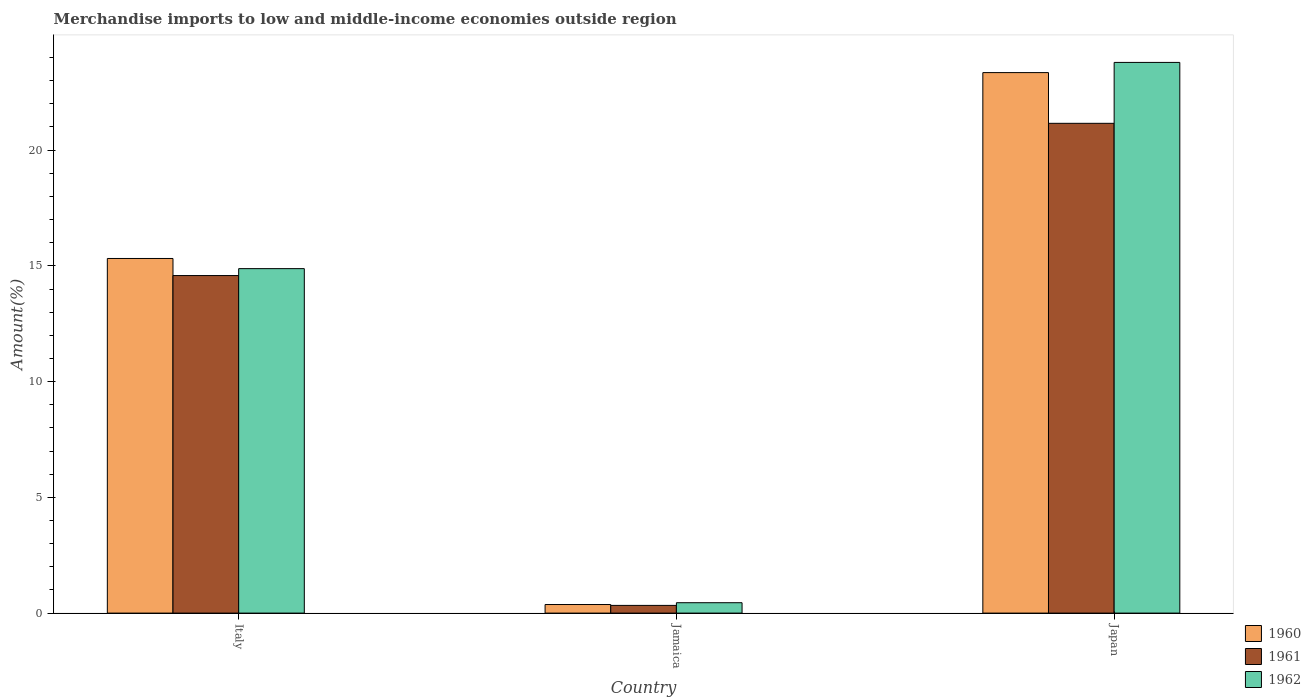How many different coloured bars are there?
Offer a very short reply. 3. How many bars are there on the 1st tick from the left?
Keep it short and to the point. 3. What is the label of the 2nd group of bars from the left?
Your answer should be very brief. Jamaica. What is the percentage of amount earned from merchandise imports in 1960 in Italy?
Your answer should be very brief. 15.32. Across all countries, what is the maximum percentage of amount earned from merchandise imports in 1960?
Offer a very short reply. 23.35. Across all countries, what is the minimum percentage of amount earned from merchandise imports in 1962?
Your answer should be very brief. 0.45. In which country was the percentage of amount earned from merchandise imports in 1962 minimum?
Keep it short and to the point. Jamaica. What is the total percentage of amount earned from merchandise imports in 1961 in the graph?
Your answer should be compact. 36.07. What is the difference between the percentage of amount earned from merchandise imports in 1962 in Jamaica and that in Japan?
Make the answer very short. -23.34. What is the difference between the percentage of amount earned from merchandise imports in 1962 in Jamaica and the percentage of amount earned from merchandise imports in 1961 in Japan?
Your answer should be compact. -20.71. What is the average percentage of amount earned from merchandise imports in 1962 per country?
Your answer should be compact. 13.04. What is the difference between the percentage of amount earned from merchandise imports of/in 1961 and percentage of amount earned from merchandise imports of/in 1962 in Jamaica?
Keep it short and to the point. -0.12. In how many countries, is the percentage of amount earned from merchandise imports in 1960 greater than 19 %?
Your answer should be very brief. 1. What is the ratio of the percentage of amount earned from merchandise imports in 1960 in Italy to that in Jamaica?
Give a very brief answer. 41.38. Is the percentage of amount earned from merchandise imports in 1961 in Italy less than that in Jamaica?
Provide a short and direct response. No. Is the difference between the percentage of amount earned from merchandise imports in 1961 in Jamaica and Japan greater than the difference between the percentage of amount earned from merchandise imports in 1962 in Jamaica and Japan?
Your answer should be very brief. Yes. What is the difference between the highest and the second highest percentage of amount earned from merchandise imports in 1960?
Make the answer very short. -14.95. What is the difference between the highest and the lowest percentage of amount earned from merchandise imports in 1962?
Provide a short and direct response. 23.34. Is the sum of the percentage of amount earned from merchandise imports in 1960 in Jamaica and Japan greater than the maximum percentage of amount earned from merchandise imports in 1961 across all countries?
Ensure brevity in your answer.  Yes. What does the 1st bar from the left in Japan represents?
Make the answer very short. 1960. What does the 1st bar from the right in Japan represents?
Your answer should be compact. 1962. Is it the case that in every country, the sum of the percentage of amount earned from merchandise imports in 1961 and percentage of amount earned from merchandise imports in 1960 is greater than the percentage of amount earned from merchandise imports in 1962?
Keep it short and to the point. Yes. How many bars are there?
Ensure brevity in your answer.  9. Are the values on the major ticks of Y-axis written in scientific E-notation?
Provide a succinct answer. No. Does the graph contain any zero values?
Ensure brevity in your answer.  No. Where does the legend appear in the graph?
Your response must be concise. Bottom right. How many legend labels are there?
Offer a very short reply. 3. How are the legend labels stacked?
Your answer should be very brief. Vertical. What is the title of the graph?
Your response must be concise. Merchandise imports to low and middle-income economies outside region. What is the label or title of the X-axis?
Keep it short and to the point. Country. What is the label or title of the Y-axis?
Offer a very short reply. Amount(%). What is the Amount(%) in 1960 in Italy?
Keep it short and to the point. 15.32. What is the Amount(%) in 1961 in Italy?
Provide a succinct answer. 14.58. What is the Amount(%) in 1962 in Italy?
Give a very brief answer. 14.88. What is the Amount(%) in 1960 in Jamaica?
Your answer should be compact. 0.37. What is the Amount(%) in 1961 in Jamaica?
Your answer should be very brief. 0.33. What is the Amount(%) in 1962 in Jamaica?
Give a very brief answer. 0.45. What is the Amount(%) in 1960 in Japan?
Keep it short and to the point. 23.35. What is the Amount(%) in 1961 in Japan?
Your answer should be very brief. 21.16. What is the Amount(%) in 1962 in Japan?
Ensure brevity in your answer.  23.79. Across all countries, what is the maximum Amount(%) in 1960?
Provide a succinct answer. 23.35. Across all countries, what is the maximum Amount(%) of 1961?
Provide a succinct answer. 21.16. Across all countries, what is the maximum Amount(%) of 1962?
Your response must be concise. 23.79. Across all countries, what is the minimum Amount(%) of 1960?
Offer a very short reply. 0.37. Across all countries, what is the minimum Amount(%) in 1961?
Keep it short and to the point. 0.33. Across all countries, what is the minimum Amount(%) of 1962?
Provide a short and direct response. 0.45. What is the total Amount(%) in 1960 in the graph?
Offer a terse response. 39.04. What is the total Amount(%) of 1961 in the graph?
Give a very brief answer. 36.07. What is the total Amount(%) in 1962 in the graph?
Provide a succinct answer. 39.12. What is the difference between the Amount(%) of 1960 in Italy and that in Jamaica?
Provide a short and direct response. 14.95. What is the difference between the Amount(%) in 1961 in Italy and that in Jamaica?
Provide a short and direct response. 14.25. What is the difference between the Amount(%) in 1962 in Italy and that in Jamaica?
Keep it short and to the point. 14.43. What is the difference between the Amount(%) of 1960 in Italy and that in Japan?
Offer a terse response. -8.03. What is the difference between the Amount(%) in 1961 in Italy and that in Japan?
Provide a short and direct response. -6.58. What is the difference between the Amount(%) in 1962 in Italy and that in Japan?
Ensure brevity in your answer.  -8.91. What is the difference between the Amount(%) of 1960 in Jamaica and that in Japan?
Offer a terse response. -22.98. What is the difference between the Amount(%) of 1961 in Jamaica and that in Japan?
Your response must be concise. -20.83. What is the difference between the Amount(%) of 1962 in Jamaica and that in Japan?
Keep it short and to the point. -23.34. What is the difference between the Amount(%) in 1960 in Italy and the Amount(%) in 1961 in Jamaica?
Provide a short and direct response. 14.99. What is the difference between the Amount(%) of 1960 in Italy and the Amount(%) of 1962 in Jamaica?
Your answer should be very brief. 14.87. What is the difference between the Amount(%) of 1961 in Italy and the Amount(%) of 1962 in Jamaica?
Your response must be concise. 14.13. What is the difference between the Amount(%) in 1960 in Italy and the Amount(%) in 1961 in Japan?
Provide a succinct answer. -5.84. What is the difference between the Amount(%) in 1960 in Italy and the Amount(%) in 1962 in Japan?
Your answer should be compact. -8.47. What is the difference between the Amount(%) in 1961 in Italy and the Amount(%) in 1962 in Japan?
Your answer should be compact. -9.21. What is the difference between the Amount(%) of 1960 in Jamaica and the Amount(%) of 1961 in Japan?
Your response must be concise. -20.79. What is the difference between the Amount(%) of 1960 in Jamaica and the Amount(%) of 1962 in Japan?
Ensure brevity in your answer.  -23.42. What is the difference between the Amount(%) of 1961 in Jamaica and the Amount(%) of 1962 in Japan?
Your response must be concise. -23.46. What is the average Amount(%) of 1960 per country?
Provide a succinct answer. 13.01. What is the average Amount(%) in 1961 per country?
Offer a very short reply. 12.02. What is the average Amount(%) in 1962 per country?
Offer a terse response. 13.04. What is the difference between the Amount(%) of 1960 and Amount(%) of 1961 in Italy?
Provide a succinct answer. 0.74. What is the difference between the Amount(%) of 1960 and Amount(%) of 1962 in Italy?
Your answer should be compact. 0.44. What is the difference between the Amount(%) of 1961 and Amount(%) of 1962 in Italy?
Provide a succinct answer. -0.3. What is the difference between the Amount(%) of 1960 and Amount(%) of 1961 in Jamaica?
Provide a succinct answer. 0.04. What is the difference between the Amount(%) of 1960 and Amount(%) of 1962 in Jamaica?
Make the answer very short. -0.08. What is the difference between the Amount(%) in 1961 and Amount(%) in 1962 in Jamaica?
Provide a succinct answer. -0.12. What is the difference between the Amount(%) in 1960 and Amount(%) in 1961 in Japan?
Give a very brief answer. 2.19. What is the difference between the Amount(%) of 1960 and Amount(%) of 1962 in Japan?
Ensure brevity in your answer.  -0.44. What is the difference between the Amount(%) in 1961 and Amount(%) in 1962 in Japan?
Offer a very short reply. -2.63. What is the ratio of the Amount(%) of 1960 in Italy to that in Jamaica?
Ensure brevity in your answer.  41.38. What is the ratio of the Amount(%) of 1961 in Italy to that in Jamaica?
Provide a succinct answer. 43.83. What is the ratio of the Amount(%) in 1962 in Italy to that in Jamaica?
Ensure brevity in your answer.  33.17. What is the ratio of the Amount(%) of 1960 in Italy to that in Japan?
Your answer should be very brief. 0.66. What is the ratio of the Amount(%) of 1961 in Italy to that in Japan?
Offer a terse response. 0.69. What is the ratio of the Amount(%) of 1962 in Italy to that in Japan?
Your answer should be very brief. 0.63. What is the ratio of the Amount(%) of 1960 in Jamaica to that in Japan?
Make the answer very short. 0.02. What is the ratio of the Amount(%) of 1961 in Jamaica to that in Japan?
Provide a succinct answer. 0.02. What is the ratio of the Amount(%) of 1962 in Jamaica to that in Japan?
Provide a short and direct response. 0.02. What is the difference between the highest and the second highest Amount(%) in 1960?
Offer a terse response. 8.03. What is the difference between the highest and the second highest Amount(%) in 1961?
Provide a succinct answer. 6.58. What is the difference between the highest and the second highest Amount(%) of 1962?
Provide a succinct answer. 8.91. What is the difference between the highest and the lowest Amount(%) in 1960?
Provide a succinct answer. 22.98. What is the difference between the highest and the lowest Amount(%) in 1961?
Your answer should be compact. 20.83. What is the difference between the highest and the lowest Amount(%) in 1962?
Keep it short and to the point. 23.34. 